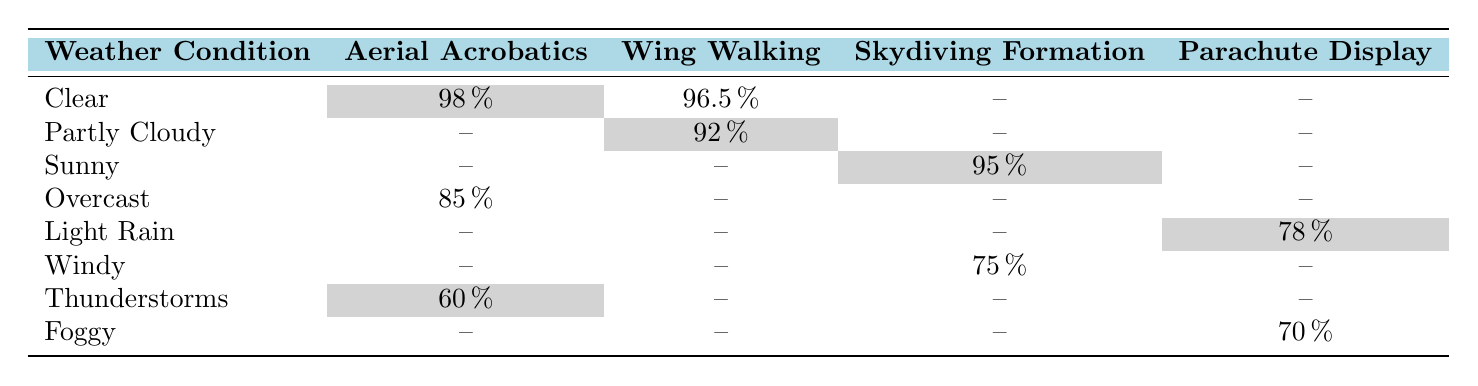What is the success rate for Aerial Acrobatics in clear weather? In the row for clear weather under the Aerial Acrobatics column, the success rate is listed as 98 percent.
Answer: 98 percent Which stunt type has the highest success rate in foggy conditions? The table shows that Parachute Display has a success rate of 70 percent and no other stunt types are listed under foggy conditions, making it the only one and therefore the highest.
Answer: 70 percent Is the success rate for Wing Walking higher in clear conditions compared to overcast conditions? In clear conditions, Wing Walking has a success rate of 96.5 percent, while in overcast conditions it is not listed, and hence it is not possible to compare a specific value. Therefore, the answer is yes because clear conditions have a higher rate with 96.5 percent.
Answer: Yes What is the average success rate for stunts performed in rainy weather conditions? The only rainy condition listed is light rain with a success rate of 78 percent. Since there are no other rainy conditions to average with, the average success rate remains 78 percent.
Answer: 78 percent Are there any stunt types listed under thunderstorms? The only stunt type listed under thunderstorms is Aerial Acrobatics, which has a success rate of 60 percent. Therefore, the answer is affirmative.
Answer: Yes What is the difference in success rates between Sunny and Thunderstorm conditions for stunts? Sunny has a success rate of 95 percent for Skydiving Formation, while Thunderstorms has a success rate of 60 percent for Aerial Acrobatics. To find the difference, subtract 60 from 95, which gives us 35.
Answer: 35 Which weather condition has the lowest success rate for stunts? Looking at the table, Thunderstorms has a 60 percent success rate, which is the lowest value when comparing all the stunt conditions listed.
Answer: 60 percent In which weather condition did Wing Walking achieve its highest success rate? Wing Walking achieved its highest success rate of 96.5 percent, which is listed under Clear conditions.
Answer: Clear conditions What is the success rate for performances in windy conditions? The table mentions that in windy conditions, Skydiving Formation has a success rate of 75 percent, which is the only stunt type listed for this weather condition.
Answer: 75 percent 